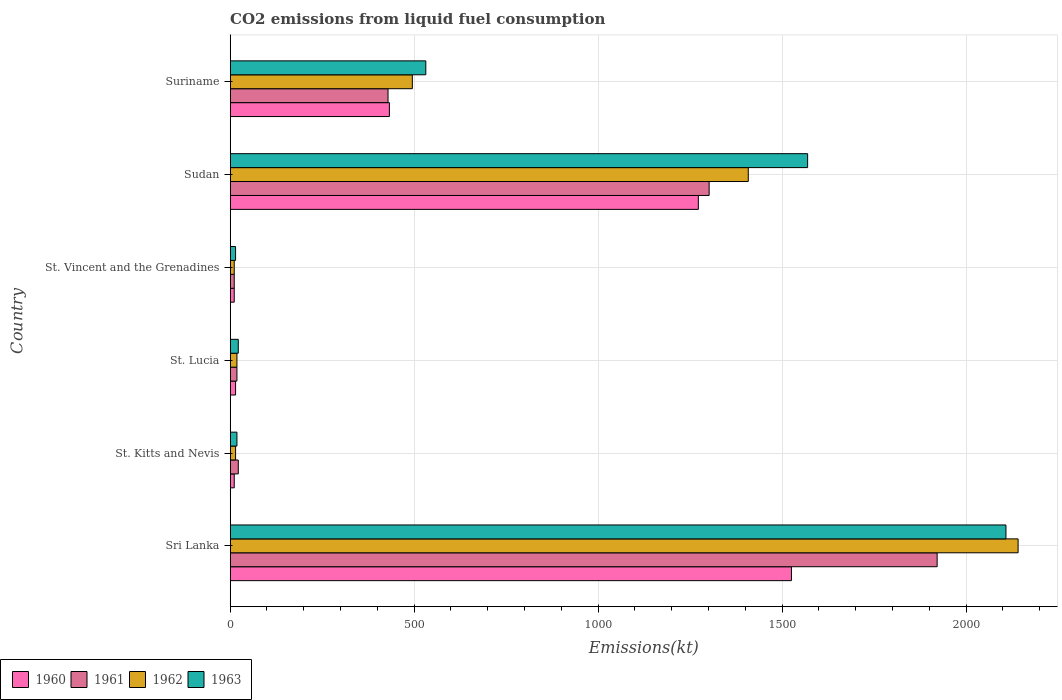How many different coloured bars are there?
Provide a short and direct response. 4. How many groups of bars are there?
Your response must be concise. 6. Are the number of bars per tick equal to the number of legend labels?
Provide a succinct answer. Yes. Are the number of bars on each tick of the Y-axis equal?
Keep it short and to the point. Yes. What is the label of the 4th group of bars from the top?
Keep it short and to the point. St. Lucia. In how many cases, is the number of bars for a given country not equal to the number of legend labels?
Make the answer very short. 0. What is the amount of CO2 emitted in 1962 in Suriname?
Offer a very short reply. 495.05. Across all countries, what is the maximum amount of CO2 emitted in 1961?
Your answer should be very brief. 1921.51. Across all countries, what is the minimum amount of CO2 emitted in 1963?
Offer a terse response. 14.67. In which country was the amount of CO2 emitted in 1961 maximum?
Keep it short and to the point. Sri Lanka. In which country was the amount of CO2 emitted in 1962 minimum?
Provide a succinct answer. St. Vincent and the Grenadines. What is the total amount of CO2 emitted in 1963 in the graph?
Ensure brevity in your answer.  4264.72. What is the difference between the amount of CO2 emitted in 1961 in St. Kitts and Nevis and that in St. Lucia?
Keep it short and to the point. 3.67. What is the difference between the amount of CO2 emitted in 1963 in Sudan and the amount of CO2 emitted in 1962 in Sri Lanka?
Offer a very short reply. -572.05. What is the average amount of CO2 emitted in 1960 per country?
Your answer should be compact. 544.55. What is the difference between the amount of CO2 emitted in 1961 and amount of CO2 emitted in 1963 in Sri Lanka?
Make the answer very short. -187.02. What is the ratio of the amount of CO2 emitted in 1960 in St. Kitts and Nevis to that in Suriname?
Ensure brevity in your answer.  0.03. Is the amount of CO2 emitted in 1962 in St. Lucia less than that in Suriname?
Keep it short and to the point. Yes. Is the difference between the amount of CO2 emitted in 1961 in Sri Lanka and Sudan greater than the difference between the amount of CO2 emitted in 1963 in Sri Lanka and Sudan?
Provide a short and direct response. Yes. What is the difference between the highest and the second highest amount of CO2 emitted in 1962?
Provide a short and direct response. 733.4. What is the difference between the highest and the lowest amount of CO2 emitted in 1960?
Your answer should be compact. 1514.47. In how many countries, is the amount of CO2 emitted in 1962 greater than the average amount of CO2 emitted in 1962 taken over all countries?
Offer a very short reply. 2. What does the 2nd bar from the top in St. Kitts and Nevis represents?
Your answer should be very brief. 1962. Is it the case that in every country, the sum of the amount of CO2 emitted in 1962 and amount of CO2 emitted in 1960 is greater than the amount of CO2 emitted in 1961?
Provide a short and direct response. Yes. Are all the bars in the graph horizontal?
Provide a short and direct response. Yes. What is the difference between two consecutive major ticks on the X-axis?
Ensure brevity in your answer.  500. Are the values on the major ticks of X-axis written in scientific E-notation?
Your response must be concise. No. Does the graph contain grids?
Your answer should be very brief. Yes. How are the legend labels stacked?
Offer a terse response. Horizontal. What is the title of the graph?
Provide a short and direct response. CO2 emissions from liquid fuel consumption. What is the label or title of the X-axis?
Offer a terse response. Emissions(kt). What is the Emissions(kt) of 1960 in Sri Lanka?
Provide a succinct answer. 1525.47. What is the Emissions(kt) of 1961 in Sri Lanka?
Your response must be concise. 1921.51. What is the Emissions(kt) of 1962 in Sri Lanka?
Ensure brevity in your answer.  2141.53. What is the Emissions(kt) of 1963 in Sri Lanka?
Offer a very short reply. 2108.53. What is the Emissions(kt) in 1960 in St. Kitts and Nevis?
Keep it short and to the point. 11. What is the Emissions(kt) of 1961 in St. Kitts and Nevis?
Your answer should be very brief. 22. What is the Emissions(kt) in 1962 in St. Kitts and Nevis?
Offer a terse response. 14.67. What is the Emissions(kt) of 1963 in St. Kitts and Nevis?
Provide a succinct answer. 18.34. What is the Emissions(kt) of 1960 in St. Lucia?
Your response must be concise. 14.67. What is the Emissions(kt) in 1961 in St. Lucia?
Ensure brevity in your answer.  18.34. What is the Emissions(kt) of 1962 in St. Lucia?
Your answer should be very brief. 18.34. What is the Emissions(kt) in 1963 in St. Lucia?
Offer a very short reply. 22. What is the Emissions(kt) of 1960 in St. Vincent and the Grenadines?
Ensure brevity in your answer.  11. What is the Emissions(kt) of 1961 in St. Vincent and the Grenadines?
Your answer should be very brief. 11. What is the Emissions(kt) of 1962 in St. Vincent and the Grenadines?
Your response must be concise. 11. What is the Emissions(kt) of 1963 in St. Vincent and the Grenadines?
Your answer should be very brief. 14.67. What is the Emissions(kt) of 1960 in Sudan?
Give a very brief answer. 1272.45. What is the Emissions(kt) of 1961 in Sudan?
Ensure brevity in your answer.  1301.79. What is the Emissions(kt) in 1962 in Sudan?
Offer a terse response. 1408.13. What is the Emissions(kt) of 1963 in Sudan?
Your response must be concise. 1569.48. What is the Emissions(kt) in 1960 in Suriname?
Provide a short and direct response. 432.71. What is the Emissions(kt) of 1961 in Suriname?
Provide a succinct answer. 429.04. What is the Emissions(kt) in 1962 in Suriname?
Ensure brevity in your answer.  495.05. What is the Emissions(kt) of 1963 in Suriname?
Offer a very short reply. 531.72. Across all countries, what is the maximum Emissions(kt) of 1960?
Keep it short and to the point. 1525.47. Across all countries, what is the maximum Emissions(kt) of 1961?
Your answer should be very brief. 1921.51. Across all countries, what is the maximum Emissions(kt) of 1962?
Your answer should be very brief. 2141.53. Across all countries, what is the maximum Emissions(kt) of 1963?
Offer a very short reply. 2108.53. Across all countries, what is the minimum Emissions(kt) of 1960?
Provide a short and direct response. 11. Across all countries, what is the minimum Emissions(kt) in 1961?
Provide a short and direct response. 11. Across all countries, what is the minimum Emissions(kt) of 1962?
Keep it short and to the point. 11. Across all countries, what is the minimum Emissions(kt) of 1963?
Provide a succinct answer. 14.67. What is the total Emissions(kt) in 1960 in the graph?
Your response must be concise. 3267.3. What is the total Emissions(kt) in 1961 in the graph?
Offer a very short reply. 3703.67. What is the total Emissions(kt) of 1962 in the graph?
Offer a terse response. 4088.7. What is the total Emissions(kt) of 1963 in the graph?
Make the answer very short. 4264.72. What is the difference between the Emissions(kt) in 1960 in Sri Lanka and that in St. Kitts and Nevis?
Your answer should be compact. 1514.47. What is the difference between the Emissions(kt) of 1961 in Sri Lanka and that in St. Kitts and Nevis?
Offer a terse response. 1899.51. What is the difference between the Emissions(kt) of 1962 in Sri Lanka and that in St. Kitts and Nevis?
Offer a very short reply. 2126.86. What is the difference between the Emissions(kt) in 1963 in Sri Lanka and that in St. Kitts and Nevis?
Provide a succinct answer. 2090.19. What is the difference between the Emissions(kt) in 1960 in Sri Lanka and that in St. Lucia?
Ensure brevity in your answer.  1510.8. What is the difference between the Emissions(kt) in 1961 in Sri Lanka and that in St. Lucia?
Offer a very short reply. 1903.17. What is the difference between the Emissions(kt) of 1962 in Sri Lanka and that in St. Lucia?
Your response must be concise. 2123.19. What is the difference between the Emissions(kt) of 1963 in Sri Lanka and that in St. Lucia?
Your answer should be compact. 2086.52. What is the difference between the Emissions(kt) of 1960 in Sri Lanka and that in St. Vincent and the Grenadines?
Provide a succinct answer. 1514.47. What is the difference between the Emissions(kt) in 1961 in Sri Lanka and that in St. Vincent and the Grenadines?
Your answer should be very brief. 1910.51. What is the difference between the Emissions(kt) in 1962 in Sri Lanka and that in St. Vincent and the Grenadines?
Offer a terse response. 2130.53. What is the difference between the Emissions(kt) of 1963 in Sri Lanka and that in St. Vincent and the Grenadines?
Your answer should be very brief. 2093.86. What is the difference between the Emissions(kt) in 1960 in Sri Lanka and that in Sudan?
Keep it short and to the point. 253.02. What is the difference between the Emissions(kt) in 1961 in Sri Lanka and that in Sudan?
Your response must be concise. 619.72. What is the difference between the Emissions(kt) in 1962 in Sri Lanka and that in Sudan?
Give a very brief answer. 733.4. What is the difference between the Emissions(kt) of 1963 in Sri Lanka and that in Sudan?
Your response must be concise. 539.05. What is the difference between the Emissions(kt) of 1960 in Sri Lanka and that in Suriname?
Give a very brief answer. 1092.77. What is the difference between the Emissions(kt) in 1961 in Sri Lanka and that in Suriname?
Keep it short and to the point. 1492.47. What is the difference between the Emissions(kt) of 1962 in Sri Lanka and that in Suriname?
Provide a succinct answer. 1646.48. What is the difference between the Emissions(kt) in 1963 in Sri Lanka and that in Suriname?
Offer a terse response. 1576.81. What is the difference between the Emissions(kt) in 1960 in St. Kitts and Nevis and that in St. Lucia?
Keep it short and to the point. -3.67. What is the difference between the Emissions(kt) of 1961 in St. Kitts and Nevis and that in St. Lucia?
Your response must be concise. 3.67. What is the difference between the Emissions(kt) of 1962 in St. Kitts and Nevis and that in St. Lucia?
Make the answer very short. -3.67. What is the difference between the Emissions(kt) of 1963 in St. Kitts and Nevis and that in St. Lucia?
Your answer should be very brief. -3.67. What is the difference between the Emissions(kt) of 1960 in St. Kitts and Nevis and that in St. Vincent and the Grenadines?
Provide a succinct answer. 0. What is the difference between the Emissions(kt) in 1961 in St. Kitts and Nevis and that in St. Vincent and the Grenadines?
Give a very brief answer. 11. What is the difference between the Emissions(kt) in 1962 in St. Kitts and Nevis and that in St. Vincent and the Grenadines?
Your answer should be compact. 3.67. What is the difference between the Emissions(kt) of 1963 in St. Kitts and Nevis and that in St. Vincent and the Grenadines?
Give a very brief answer. 3.67. What is the difference between the Emissions(kt) of 1960 in St. Kitts and Nevis and that in Sudan?
Your answer should be very brief. -1261.45. What is the difference between the Emissions(kt) of 1961 in St. Kitts and Nevis and that in Sudan?
Your answer should be very brief. -1279.78. What is the difference between the Emissions(kt) in 1962 in St. Kitts and Nevis and that in Sudan?
Offer a very short reply. -1393.46. What is the difference between the Emissions(kt) in 1963 in St. Kitts and Nevis and that in Sudan?
Offer a very short reply. -1551.14. What is the difference between the Emissions(kt) of 1960 in St. Kitts and Nevis and that in Suriname?
Your response must be concise. -421.7. What is the difference between the Emissions(kt) of 1961 in St. Kitts and Nevis and that in Suriname?
Ensure brevity in your answer.  -407.04. What is the difference between the Emissions(kt) in 1962 in St. Kitts and Nevis and that in Suriname?
Provide a succinct answer. -480.38. What is the difference between the Emissions(kt) in 1963 in St. Kitts and Nevis and that in Suriname?
Ensure brevity in your answer.  -513.38. What is the difference between the Emissions(kt) in 1960 in St. Lucia and that in St. Vincent and the Grenadines?
Keep it short and to the point. 3.67. What is the difference between the Emissions(kt) in 1961 in St. Lucia and that in St. Vincent and the Grenadines?
Offer a very short reply. 7.33. What is the difference between the Emissions(kt) of 1962 in St. Lucia and that in St. Vincent and the Grenadines?
Offer a very short reply. 7.33. What is the difference between the Emissions(kt) of 1963 in St. Lucia and that in St. Vincent and the Grenadines?
Offer a terse response. 7.33. What is the difference between the Emissions(kt) of 1960 in St. Lucia and that in Sudan?
Offer a terse response. -1257.78. What is the difference between the Emissions(kt) of 1961 in St. Lucia and that in Sudan?
Offer a terse response. -1283.45. What is the difference between the Emissions(kt) in 1962 in St. Lucia and that in Sudan?
Your response must be concise. -1389.79. What is the difference between the Emissions(kt) in 1963 in St. Lucia and that in Sudan?
Keep it short and to the point. -1547.47. What is the difference between the Emissions(kt) of 1960 in St. Lucia and that in Suriname?
Your answer should be very brief. -418.04. What is the difference between the Emissions(kt) of 1961 in St. Lucia and that in Suriname?
Your answer should be compact. -410.7. What is the difference between the Emissions(kt) of 1962 in St. Lucia and that in Suriname?
Offer a terse response. -476.71. What is the difference between the Emissions(kt) of 1963 in St. Lucia and that in Suriname?
Your answer should be very brief. -509.71. What is the difference between the Emissions(kt) of 1960 in St. Vincent and the Grenadines and that in Sudan?
Your answer should be compact. -1261.45. What is the difference between the Emissions(kt) of 1961 in St. Vincent and the Grenadines and that in Sudan?
Your answer should be compact. -1290.78. What is the difference between the Emissions(kt) of 1962 in St. Vincent and the Grenadines and that in Sudan?
Keep it short and to the point. -1397.13. What is the difference between the Emissions(kt) of 1963 in St. Vincent and the Grenadines and that in Sudan?
Provide a succinct answer. -1554.81. What is the difference between the Emissions(kt) of 1960 in St. Vincent and the Grenadines and that in Suriname?
Give a very brief answer. -421.7. What is the difference between the Emissions(kt) of 1961 in St. Vincent and the Grenadines and that in Suriname?
Provide a succinct answer. -418.04. What is the difference between the Emissions(kt) of 1962 in St. Vincent and the Grenadines and that in Suriname?
Offer a very short reply. -484.04. What is the difference between the Emissions(kt) of 1963 in St. Vincent and the Grenadines and that in Suriname?
Offer a terse response. -517.05. What is the difference between the Emissions(kt) in 1960 in Sudan and that in Suriname?
Offer a very short reply. 839.74. What is the difference between the Emissions(kt) of 1961 in Sudan and that in Suriname?
Offer a terse response. 872.75. What is the difference between the Emissions(kt) in 1962 in Sudan and that in Suriname?
Your answer should be compact. 913.08. What is the difference between the Emissions(kt) of 1963 in Sudan and that in Suriname?
Offer a terse response. 1037.76. What is the difference between the Emissions(kt) of 1960 in Sri Lanka and the Emissions(kt) of 1961 in St. Kitts and Nevis?
Offer a terse response. 1503.47. What is the difference between the Emissions(kt) of 1960 in Sri Lanka and the Emissions(kt) of 1962 in St. Kitts and Nevis?
Make the answer very short. 1510.8. What is the difference between the Emissions(kt) in 1960 in Sri Lanka and the Emissions(kt) in 1963 in St. Kitts and Nevis?
Offer a very short reply. 1507.14. What is the difference between the Emissions(kt) in 1961 in Sri Lanka and the Emissions(kt) in 1962 in St. Kitts and Nevis?
Make the answer very short. 1906.84. What is the difference between the Emissions(kt) of 1961 in Sri Lanka and the Emissions(kt) of 1963 in St. Kitts and Nevis?
Offer a very short reply. 1903.17. What is the difference between the Emissions(kt) of 1962 in Sri Lanka and the Emissions(kt) of 1963 in St. Kitts and Nevis?
Keep it short and to the point. 2123.19. What is the difference between the Emissions(kt) in 1960 in Sri Lanka and the Emissions(kt) in 1961 in St. Lucia?
Offer a very short reply. 1507.14. What is the difference between the Emissions(kt) of 1960 in Sri Lanka and the Emissions(kt) of 1962 in St. Lucia?
Your response must be concise. 1507.14. What is the difference between the Emissions(kt) in 1960 in Sri Lanka and the Emissions(kt) in 1963 in St. Lucia?
Your response must be concise. 1503.47. What is the difference between the Emissions(kt) in 1961 in Sri Lanka and the Emissions(kt) in 1962 in St. Lucia?
Offer a terse response. 1903.17. What is the difference between the Emissions(kt) in 1961 in Sri Lanka and the Emissions(kt) in 1963 in St. Lucia?
Your response must be concise. 1899.51. What is the difference between the Emissions(kt) of 1962 in Sri Lanka and the Emissions(kt) of 1963 in St. Lucia?
Your response must be concise. 2119.53. What is the difference between the Emissions(kt) in 1960 in Sri Lanka and the Emissions(kt) in 1961 in St. Vincent and the Grenadines?
Provide a succinct answer. 1514.47. What is the difference between the Emissions(kt) of 1960 in Sri Lanka and the Emissions(kt) of 1962 in St. Vincent and the Grenadines?
Your answer should be very brief. 1514.47. What is the difference between the Emissions(kt) of 1960 in Sri Lanka and the Emissions(kt) of 1963 in St. Vincent and the Grenadines?
Offer a very short reply. 1510.8. What is the difference between the Emissions(kt) of 1961 in Sri Lanka and the Emissions(kt) of 1962 in St. Vincent and the Grenadines?
Your answer should be very brief. 1910.51. What is the difference between the Emissions(kt) of 1961 in Sri Lanka and the Emissions(kt) of 1963 in St. Vincent and the Grenadines?
Make the answer very short. 1906.84. What is the difference between the Emissions(kt) of 1962 in Sri Lanka and the Emissions(kt) of 1963 in St. Vincent and the Grenadines?
Your answer should be very brief. 2126.86. What is the difference between the Emissions(kt) in 1960 in Sri Lanka and the Emissions(kt) in 1961 in Sudan?
Keep it short and to the point. 223.69. What is the difference between the Emissions(kt) of 1960 in Sri Lanka and the Emissions(kt) of 1962 in Sudan?
Make the answer very short. 117.34. What is the difference between the Emissions(kt) in 1960 in Sri Lanka and the Emissions(kt) in 1963 in Sudan?
Ensure brevity in your answer.  -44. What is the difference between the Emissions(kt) of 1961 in Sri Lanka and the Emissions(kt) of 1962 in Sudan?
Your answer should be compact. 513.38. What is the difference between the Emissions(kt) in 1961 in Sri Lanka and the Emissions(kt) in 1963 in Sudan?
Offer a terse response. 352.03. What is the difference between the Emissions(kt) of 1962 in Sri Lanka and the Emissions(kt) of 1963 in Sudan?
Keep it short and to the point. 572.05. What is the difference between the Emissions(kt) of 1960 in Sri Lanka and the Emissions(kt) of 1961 in Suriname?
Offer a terse response. 1096.43. What is the difference between the Emissions(kt) in 1960 in Sri Lanka and the Emissions(kt) in 1962 in Suriname?
Offer a terse response. 1030.43. What is the difference between the Emissions(kt) in 1960 in Sri Lanka and the Emissions(kt) in 1963 in Suriname?
Make the answer very short. 993.76. What is the difference between the Emissions(kt) in 1961 in Sri Lanka and the Emissions(kt) in 1962 in Suriname?
Your answer should be very brief. 1426.46. What is the difference between the Emissions(kt) in 1961 in Sri Lanka and the Emissions(kt) in 1963 in Suriname?
Make the answer very short. 1389.79. What is the difference between the Emissions(kt) of 1962 in Sri Lanka and the Emissions(kt) of 1963 in Suriname?
Your answer should be very brief. 1609.81. What is the difference between the Emissions(kt) in 1960 in St. Kitts and Nevis and the Emissions(kt) in 1961 in St. Lucia?
Your answer should be very brief. -7.33. What is the difference between the Emissions(kt) of 1960 in St. Kitts and Nevis and the Emissions(kt) of 1962 in St. Lucia?
Offer a terse response. -7.33. What is the difference between the Emissions(kt) of 1960 in St. Kitts and Nevis and the Emissions(kt) of 1963 in St. Lucia?
Offer a very short reply. -11. What is the difference between the Emissions(kt) of 1961 in St. Kitts and Nevis and the Emissions(kt) of 1962 in St. Lucia?
Provide a short and direct response. 3.67. What is the difference between the Emissions(kt) in 1962 in St. Kitts and Nevis and the Emissions(kt) in 1963 in St. Lucia?
Offer a very short reply. -7.33. What is the difference between the Emissions(kt) of 1960 in St. Kitts and Nevis and the Emissions(kt) of 1961 in St. Vincent and the Grenadines?
Your answer should be very brief. 0. What is the difference between the Emissions(kt) in 1960 in St. Kitts and Nevis and the Emissions(kt) in 1963 in St. Vincent and the Grenadines?
Ensure brevity in your answer.  -3.67. What is the difference between the Emissions(kt) in 1961 in St. Kitts and Nevis and the Emissions(kt) in 1962 in St. Vincent and the Grenadines?
Make the answer very short. 11. What is the difference between the Emissions(kt) of 1961 in St. Kitts and Nevis and the Emissions(kt) of 1963 in St. Vincent and the Grenadines?
Make the answer very short. 7.33. What is the difference between the Emissions(kt) in 1960 in St. Kitts and Nevis and the Emissions(kt) in 1961 in Sudan?
Keep it short and to the point. -1290.78. What is the difference between the Emissions(kt) in 1960 in St. Kitts and Nevis and the Emissions(kt) in 1962 in Sudan?
Offer a very short reply. -1397.13. What is the difference between the Emissions(kt) of 1960 in St. Kitts and Nevis and the Emissions(kt) of 1963 in Sudan?
Offer a terse response. -1558.47. What is the difference between the Emissions(kt) in 1961 in St. Kitts and Nevis and the Emissions(kt) in 1962 in Sudan?
Keep it short and to the point. -1386.13. What is the difference between the Emissions(kt) in 1961 in St. Kitts and Nevis and the Emissions(kt) in 1963 in Sudan?
Keep it short and to the point. -1547.47. What is the difference between the Emissions(kt) in 1962 in St. Kitts and Nevis and the Emissions(kt) in 1963 in Sudan?
Give a very brief answer. -1554.81. What is the difference between the Emissions(kt) of 1960 in St. Kitts and Nevis and the Emissions(kt) of 1961 in Suriname?
Keep it short and to the point. -418.04. What is the difference between the Emissions(kt) in 1960 in St. Kitts and Nevis and the Emissions(kt) in 1962 in Suriname?
Make the answer very short. -484.04. What is the difference between the Emissions(kt) of 1960 in St. Kitts and Nevis and the Emissions(kt) of 1963 in Suriname?
Give a very brief answer. -520.71. What is the difference between the Emissions(kt) of 1961 in St. Kitts and Nevis and the Emissions(kt) of 1962 in Suriname?
Ensure brevity in your answer.  -473.04. What is the difference between the Emissions(kt) of 1961 in St. Kitts and Nevis and the Emissions(kt) of 1963 in Suriname?
Your answer should be very brief. -509.71. What is the difference between the Emissions(kt) in 1962 in St. Kitts and Nevis and the Emissions(kt) in 1963 in Suriname?
Your answer should be compact. -517.05. What is the difference between the Emissions(kt) of 1960 in St. Lucia and the Emissions(kt) of 1961 in St. Vincent and the Grenadines?
Ensure brevity in your answer.  3.67. What is the difference between the Emissions(kt) of 1960 in St. Lucia and the Emissions(kt) of 1962 in St. Vincent and the Grenadines?
Provide a succinct answer. 3.67. What is the difference between the Emissions(kt) in 1961 in St. Lucia and the Emissions(kt) in 1962 in St. Vincent and the Grenadines?
Make the answer very short. 7.33. What is the difference between the Emissions(kt) in 1961 in St. Lucia and the Emissions(kt) in 1963 in St. Vincent and the Grenadines?
Give a very brief answer. 3.67. What is the difference between the Emissions(kt) of 1962 in St. Lucia and the Emissions(kt) of 1963 in St. Vincent and the Grenadines?
Provide a short and direct response. 3.67. What is the difference between the Emissions(kt) of 1960 in St. Lucia and the Emissions(kt) of 1961 in Sudan?
Your answer should be very brief. -1287.12. What is the difference between the Emissions(kt) of 1960 in St. Lucia and the Emissions(kt) of 1962 in Sudan?
Offer a terse response. -1393.46. What is the difference between the Emissions(kt) of 1960 in St. Lucia and the Emissions(kt) of 1963 in Sudan?
Keep it short and to the point. -1554.81. What is the difference between the Emissions(kt) in 1961 in St. Lucia and the Emissions(kt) in 1962 in Sudan?
Give a very brief answer. -1389.79. What is the difference between the Emissions(kt) of 1961 in St. Lucia and the Emissions(kt) of 1963 in Sudan?
Your answer should be compact. -1551.14. What is the difference between the Emissions(kt) of 1962 in St. Lucia and the Emissions(kt) of 1963 in Sudan?
Your answer should be very brief. -1551.14. What is the difference between the Emissions(kt) of 1960 in St. Lucia and the Emissions(kt) of 1961 in Suriname?
Offer a terse response. -414.37. What is the difference between the Emissions(kt) of 1960 in St. Lucia and the Emissions(kt) of 1962 in Suriname?
Keep it short and to the point. -480.38. What is the difference between the Emissions(kt) of 1960 in St. Lucia and the Emissions(kt) of 1963 in Suriname?
Keep it short and to the point. -517.05. What is the difference between the Emissions(kt) of 1961 in St. Lucia and the Emissions(kt) of 1962 in Suriname?
Offer a very short reply. -476.71. What is the difference between the Emissions(kt) of 1961 in St. Lucia and the Emissions(kt) of 1963 in Suriname?
Your response must be concise. -513.38. What is the difference between the Emissions(kt) in 1962 in St. Lucia and the Emissions(kt) in 1963 in Suriname?
Ensure brevity in your answer.  -513.38. What is the difference between the Emissions(kt) of 1960 in St. Vincent and the Grenadines and the Emissions(kt) of 1961 in Sudan?
Your answer should be very brief. -1290.78. What is the difference between the Emissions(kt) in 1960 in St. Vincent and the Grenadines and the Emissions(kt) in 1962 in Sudan?
Offer a terse response. -1397.13. What is the difference between the Emissions(kt) of 1960 in St. Vincent and the Grenadines and the Emissions(kt) of 1963 in Sudan?
Offer a very short reply. -1558.47. What is the difference between the Emissions(kt) in 1961 in St. Vincent and the Grenadines and the Emissions(kt) in 1962 in Sudan?
Provide a short and direct response. -1397.13. What is the difference between the Emissions(kt) in 1961 in St. Vincent and the Grenadines and the Emissions(kt) in 1963 in Sudan?
Make the answer very short. -1558.47. What is the difference between the Emissions(kt) of 1962 in St. Vincent and the Grenadines and the Emissions(kt) of 1963 in Sudan?
Offer a very short reply. -1558.47. What is the difference between the Emissions(kt) in 1960 in St. Vincent and the Grenadines and the Emissions(kt) in 1961 in Suriname?
Your response must be concise. -418.04. What is the difference between the Emissions(kt) of 1960 in St. Vincent and the Grenadines and the Emissions(kt) of 1962 in Suriname?
Provide a short and direct response. -484.04. What is the difference between the Emissions(kt) of 1960 in St. Vincent and the Grenadines and the Emissions(kt) of 1963 in Suriname?
Keep it short and to the point. -520.71. What is the difference between the Emissions(kt) in 1961 in St. Vincent and the Grenadines and the Emissions(kt) in 1962 in Suriname?
Your answer should be compact. -484.04. What is the difference between the Emissions(kt) in 1961 in St. Vincent and the Grenadines and the Emissions(kt) in 1963 in Suriname?
Provide a short and direct response. -520.71. What is the difference between the Emissions(kt) in 1962 in St. Vincent and the Grenadines and the Emissions(kt) in 1963 in Suriname?
Ensure brevity in your answer.  -520.71. What is the difference between the Emissions(kt) in 1960 in Sudan and the Emissions(kt) in 1961 in Suriname?
Make the answer very short. 843.41. What is the difference between the Emissions(kt) of 1960 in Sudan and the Emissions(kt) of 1962 in Suriname?
Provide a succinct answer. 777.4. What is the difference between the Emissions(kt) in 1960 in Sudan and the Emissions(kt) in 1963 in Suriname?
Your answer should be compact. 740.73. What is the difference between the Emissions(kt) of 1961 in Sudan and the Emissions(kt) of 1962 in Suriname?
Your answer should be compact. 806.74. What is the difference between the Emissions(kt) of 1961 in Sudan and the Emissions(kt) of 1963 in Suriname?
Offer a terse response. 770.07. What is the difference between the Emissions(kt) in 1962 in Sudan and the Emissions(kt) in 1963 in Suriname?
Keep it short and to the point. 876.41. What is the average Emissions(kt) in 1960 per country?
Provide a short and direct response. 544.55. What is the average Emissions(kt) in 1961 per country?
Provide a short and direct response. 617.28. What is the average Emissions(kt) in 1962 per country?
Provide a short and direct response. 681.45. What is the average Emissions(kt) of 1963 per country?
Offer a very short reply. 710.79. What is the difference between the Emissions(kt) in 1960 and Emissions(kt) in 1961 in Sri Lanka?
Ensure brevity in your answer.  -396.04. What is the difference between the Emissions(kt) in 1960 and Emissions(kt) in 1962 in Sri Lanka?
Your answer should be very brief. -616.06. What is the difference between the Emissions(kt) of 1960 and Emissions(kt) of 1963 in Sri Lanka?
Make the answer very short. -583.05. What is the difference between the Emissions(kt) in 1961 and Emissions(kt) in 1962 in Sri Lanka?
Provide a succinct answer. -220.02. What is the difference between the Emissions(kt) in 1961 and Emissions(kt) in 1963 in Sri Lanka?
Keep it short and to the point. -187.02. What is the difference between the Emissions(kt) in 1962 and Emissions(kt) in 1963 in Sri Lanka?
Provide a short and direct response. 33. What is the difference between the Emissions(kt) in 1960 and Emissions(kt) in 1961 in St. Kitts and Nevis?
Make the answer very short. -11. What is the difference between the Emissions(kt) in 1960 and Emissions(kt) in 1962 in St. Kitts and Nevis?
Offer a terse response. -3.67. What is the difference between the Emissions(kt) in 1960 and Emissions(kt) in 1963 in St. Kitts and Nevis?
Provide a succinct answer. -7.33. What is the difference between the Emissions(kt) in 1961 and Emissions(kt) in 1962 in St. Kitts and Nevis?
Give a very brief answer. 7.33. What is the difference between the Emissions(kt) in 1961 and Emissions(kt) in 1963 in St. Kitts and Nevis?
Offer a terse response. 3.67. What is the difference between the Emissions(kt) of 1962 and Emissions(kt) of 1963 in St. Kitts and Nevis?
Offer a very short reply. -3.67. What is the difference between the Emissions(kt) in 1960 and Emissions(kt) in 1961 in St. Lucia?
Ensure brevity in your answer.  -3.67. What is the difference between the Emissions(kt) in 1960 and Emissions(kt) in 1962 in St. Lucia?
Give a very brief answer. -3.67. What is the difference between the Emissions(kt) of 1960 and Emissions(kt) of 1963 in St. Lucia?
Give a very brief answer. -7.33. What is the difference between the Emissions(kt) of 1961 and Emissions(kt) of 1963 in St. Lucia?
Give a very brief answer. -3.67. What is the difference between the Emissions(kt) in 1962 and Emissions(kt) in 1963 in St. Lucia?
Give a very brief answer. -3.67. What is the difference between the Emissions(kt) of 1960 and Emissions(kt) of 1961 in St. Vincent and the Grenadines?
Provide a succinct answer. 0. What is the difference between the Emissions(kt) in 1960 and Emissions(kt) in 1962 in St. Vincent and the Grenadines?
Ensure brevity in your answer.  0. What is the difference between the Emissions(kt) of 1960 and Emissions(kt) of 1963 in St. Vincent and the Grenadines?
Give a very brief answer. -3.67. What is the difference between the Emissions(kt) of 1961 and Emissions(kt) of 1962 in St. Vincent and the Grenadines?
Your answer should be very brief. 0. What is the difference between the Emissions(kt) of 1961 and Emissions(kt) of 1963 in St. Vincent and the Grenadines?
Your answer should be very brief. -3.67. What is the difference between the Emissions(kt) of 1962 and Emissions(kt) of 1963 in St. Vincent and the Grenadines?
Provide a succinct answer. -3.67. What is the difference between the Emissions(kt) in 1960 and Emissions(kt) in 1961 in Sudan?
Ensure brevity in your answer.  -29.34. What is the difference between the Emissions(kt) of 1960 and Emissions(kt) of 1962 in Sudan?
Your answer should be very brief. -135.68. What is the difference between the Emissions(kt) in 1960 and Emissions(kt) in 1963 in Sudan?
Ensure brevity in your answer.  -297.03. What is the difference between the Emissions(kt) of 1961 and Emissions(kt) of 1962 in Sudan?
Offer a very short reply. -106.34. What is the difference between the Emissions(kt) in 1961 and Emissions(kt) in 1963 in Sudan?
Your answer should be compact. -267.69. What is the difference between the Emissions(kt) in 1962 and Emissions(kt) in 1963 in Sudan?
Your response must be concise. -161.35. What is the difference between the Emissions(kt) of 1960 and Emissions(kt) of 1961 in Suriname?
Ensure brevity in your answer.  3.67. What is the difference between the Emissions(kt) of 1960 and Emissions(kt) of 1962 in Suriname?
Provide a succinct answer. -62.34. What is the difference between the Emissions(kt) of 1960 and Emissions(kt) of 1963 in Suriname?
Ensure brevity in your answer.  -99.01. What is the difference between the Emissions(kt) of 1961 and Emissions(kt) of 1962 in Suriname?
Provide a short and direct response. -66.01. What is the difference between the Emissions(kt) of 1961 and Emissions(kt) of 1963 in Suriname?
Your answer should be compact. -102.68. What is the difference between the Emissions(kt) of 1962 and Emissions(kt) of 1963 in Suriname?
Make the answer very short. -36.67. What is the ratio of the Emissions(kt) in 1960 in Sri Lanka to that in St. Kitts and Nevis?
Offer a very short reply. 138.67. What is the ratio of the Emissions(kt) in 1961 in Sri Lanka to that in St. Kitts and Nevis?
Your answer should be compact. 87.33. What is the ratio of the Emissions(kt) of 1962 in Sri Lanka to that in St. Kitts and Nevis?
Make the answer very short. 146. What is the ratio of the Emissions(kt) of 1963 in Sri Lanka to that in St. Kitts and Nevis?
Provide a succinct answer. 115. What is the ratio of the Emissions(kt) in 1960 in Sri Lanka to that in St. Lucia?
Provide a short and direct response. 104. What is the ratio of the Emissions(kt) in 1961 in Sri Lanka to that in St. Lucia?
Offer a terse response. 104.8. What is the ratio of the Emissions(kt) of 1962 in Sri Lanka to that in St. Lucia?
Provide a succinct answer. 116.8. What is the ratio of the Emissions(kt) in 1963 in Sri Lanka to that in St. Lucia?
Make the answer very short. 95.83. What is the ratio of the Emissions(kt) in 1960 in Sri Lanka to that in St. Vincent and the Grenadines?
Give a very brief answer. 138.67. What is the ratio of the Emissions(kt) in 1961 in Sri Lanka to that in St. Vincent and the Grenadines?
Offer a very short reply. 174.67. What is the ratio of the Emissions(kt) of 1962 in Sri Lanka to that in St. Vincent and the Grenadines?
Make the answer very short. 194.67. What is the ratio of the Emissions(kt) in 1963 in Sri Lanka to that in St. Vincent and the Grenadines?
Offer a terse response. 143.75. What is the ratio of the Emissions(kt) of 1960 in Sri Lanka to that in Sudan?
Keep it short and to the point. 1.2. What is the ratio of the Emissions(kt) of 1961 in Sri Lanka to that in Sudan?
Provide a succinct answer. 1.48. What is the ratio of the Emissions(kt) of 1962 in Sri Lanka to that in Sudan?
Your answer should be compact. 1.52. What is the ratio of the Emissions(kt) in 1963 in Sri Lanka to that in Sudan?
Provide a succinct answer. 1.34. What is the ratio of the Emissions(kt) in 1960 in Sri Lanka to that in Suriname?
Your answer should be very brief. 3.53. What is the ratio of the Emissions(kt) of 1961 in Sri Lanka to that in Suriname?
Provide a succinct answer. 4.48. What is the ratio of the Emissions(kt) in 1962 in Sri Lanka to that in Suriname?
Offer a terse response. 4.33. What is the ratio of the Emissions(kt) in 1963 in Sri Lanka to that in Suriname?
Keep it short and to the point. 3.97. What is the ratio of the Emissions(kt) in 1960 in St. Kitts and Nevis to that in St. Lucia?
Provide a succinct answer. 0.75. What is the ratio of the Emissions(kt) of 1961 in St. Kitts and Nevis to that in St. Vincent and the Grenadines?
Make the answer very short. 2. What is the ratio of the Emissions(kt) of 1963 in St. Kitts and Nevis to that in St. Vincent and the Grenadines?
Your answer should be very brief. 1.25. What is the ratio of the Emissions(kt) of 1960 in St. Kitts and Nevis to that in Sudan?
Your answer should be very brief. 0.01. What is the ratio of the Emissions(kt) in 1961 in St. Kitts and Nevis to that in Sudan?
Offer a terse response. 0.02. What is the ratio of the Emissions(kt) in 1962 in St. Kitts and Nevis to that in Sudan?
Your answer should be compact. 0.01. What is the ratio of the Emissions(kt) in 1963 in St. Kitts and Nevis to that in Sudan?
Your answer should be compact. 0.01. What is the ratio of the Emissions(kt) in 1960 in St. Kitts and Nevis to that in Suriname?
Your response must be concise. 0.03. What is the ratio of the Emissions(kt) in 1961 in St. Kitts and Nevis to that in Suriname?
Your answer should be compact. 0.05. What is the ratio of the Emissions(kt) in 1962 in St. Kitts and Nevis to that in Suriname?
Your answer should be compact. 0.03. What is the ratio of the Emissions(kt) of 1963 in St. Kitts and Nevis to that in Suriname?
Provide a succinct answer. 0.03. What is the ratio of the Emissions(kt) of 1960 in St. Lucia to that in St. Vincent and the Grenadines?
Your response must be concise. 1.33. What is the ratio of the Emissions(kt) in 1963 in St. Lucia to that in St. Vincent and the Grenadines?
Keep it short and to the point. 1.5. What is the ratio of the Emissions(kt) of 1960 in St. Lucia to that in Sudan?
Ensure brevity in your answer.  0.01. What is the ratio of the Emissions(kt) of 1961 in St. Lucia to that in Sudan?
Ensure brevity in your answer.  0.01. What is the ratio of the Emissions(kt) in 1962 in St. Lucia to that in Sudan?
Offer a terse response. 0.01. What is the ratio of the Emissions(kt) of 1963 in St. Lucia to that in Sudan?
Give a very brief answer. 0.01. What is the ratio of the Emissions(kt) of 1960 in St. Lucia to that in Suriname?
Offer a very short reply. 0.03. What is the ratio of the Emissions(kt) of 1961 in St. Lucia to that in Suriname?
Your response must be concise. 0.04. What is the ratio of the Emissions(kt) of 1962 in St. Lucia to that in Suriname?
Your response must be concise. 0.04. What is the ratio of the Emissions(kt) of 1963 in St. Lucia to that in Suriname?
Your answer should be compact. 0.04. What is the ratio of the Emissions(kt) of 1960 in St. Vincent and the Grenadines to that in Sudan?
Your answer should be very brief. 0.01. What is the ratio of the Emissions(kt) of 1961 in St. Vincent and the Grenadines to that in Sudan?
Make the answer very short. 0.01. What is the ratio of the Emissions(kt) in 1962 in St. Vincent and the Grenadines to that in Sudan?
Offer a terse response. 0.01. What is the ratio of the Emissions(kt) of 1963 in St. Vincent and the Grenadines to that in Sudan?
Your response must be concise. 0.01. What is the ratio of the Emissions(kt) of 1960 in St. Vincent and the Grenadines to that in Suriname?
Offer a very short reply. 0.03. What is the ratio of the Emissions(kt) of 1961 in St. Vincent and the Grenadines to that in Suriname?
Your answer should be compact. 0.03. What is the ratio of the Emissions(kt) of 1962 in St. Vincent and the Grenadines to that in Suriname?
Keep it short and to the point. 0.02. What is the ratio of the Emissions(kt) of 1963 in St. Vincent and the Grenadines to that in Suriname?
Ensure brevity in your answer.  0.03. What is the ratio of the Emissions(kt) in 1960 in Sudan to that in Suriname?
Provide a short and direct response. 2.94. What is the ratio of the Emissions(kt) of 1961 in Sudan to that in Suriname?
Make the answer very short. 3.03. What is the ratio of the Emissions(kt) in 1962 in Sudan to that in Suriname?
Provide a short and direct response. 2.84. What is the ratio of the Emissions(kt) in 1963 in Sudan to that in Suriname?
Provide a succinct answer. 2.95. What is the difference between the highest and the second highest Emissions(kt) of 1960?
Offer a terse response. 253.02. What is the difference between the highest and the second highest Emissions(kt) in 1961?
Your answer should be very brief. 619.72. What is the difference between the highest and the second highest Emissions(kt) in 1962?
Your answer should be very brief. 733.4. What is the difference between the highest and the second highest Emissions(kt) in 1963?
Ensure brevity in your answer.  539.05. What is the difference between the highest and the lowest Emissions(kt) of 1960?
Your answer should be very brief. 1514.47. What is the difference between the highest and the lowest Emissions(kt) of 1961?
Your answer should be compact. 1910.51. What is the difference between the highest and the lowest Emissions(kt) in 1962?
Provide a short and direct response. 2130.53. What is the difference between the highest and the lowest Emissions(kt) of 1963?
Offer a terse response. 2093.86. 